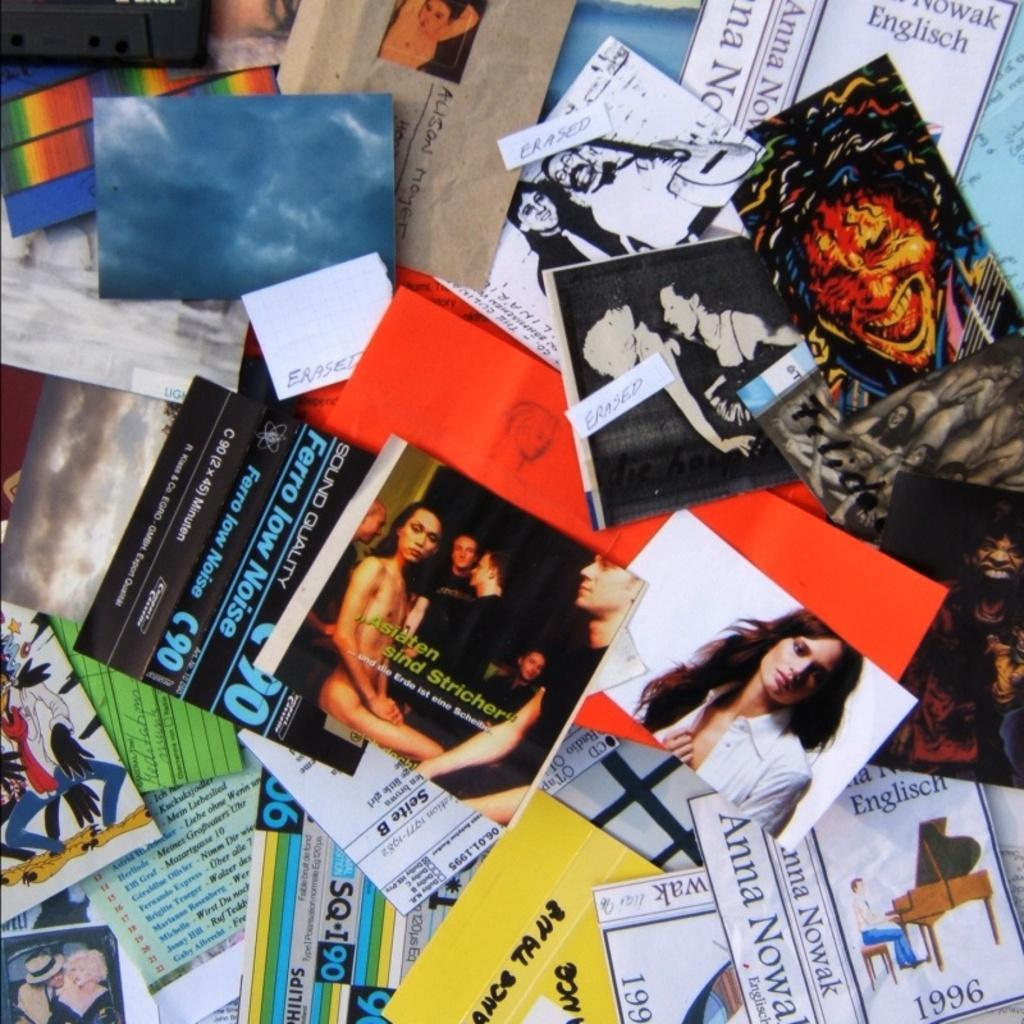Provide a one-sentence caption for the provided image. Several handbills with german sayings are scattered about on a table. 